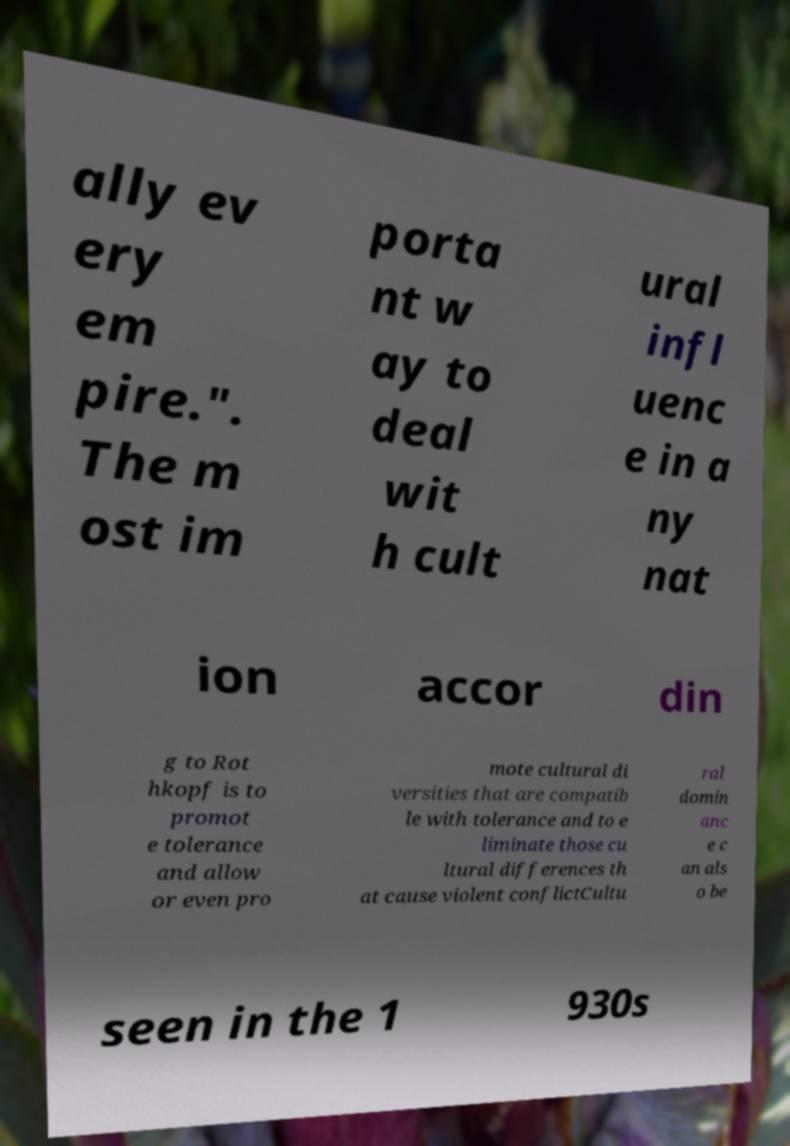Could you extract and type out the text from this image? ally ev ery em pire.". The m ost im porta nt w ay to deal wit h cult ural infl uenc e in a ny nat ion accor din g to Rot hkopf is to promot e tolerance and allow or even pro mote cultural di versities that are compatib le with tolerance and to e liminate those cu ltural differences th at cause violent conflictCultu ral domin anc e c an als o be seen in the 1 930s 